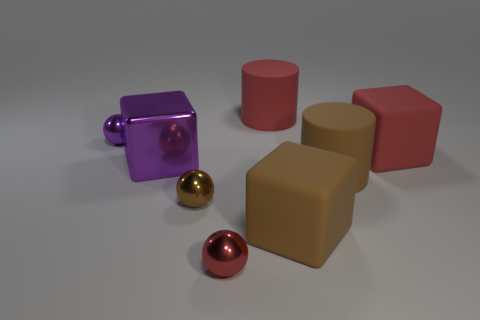What can you infer about the setting from the image? Based on the plain background and evenly distributed light, it seems like the setting is a controlled environment, likely a studio setup intended for displaying the objects without any distractions. 